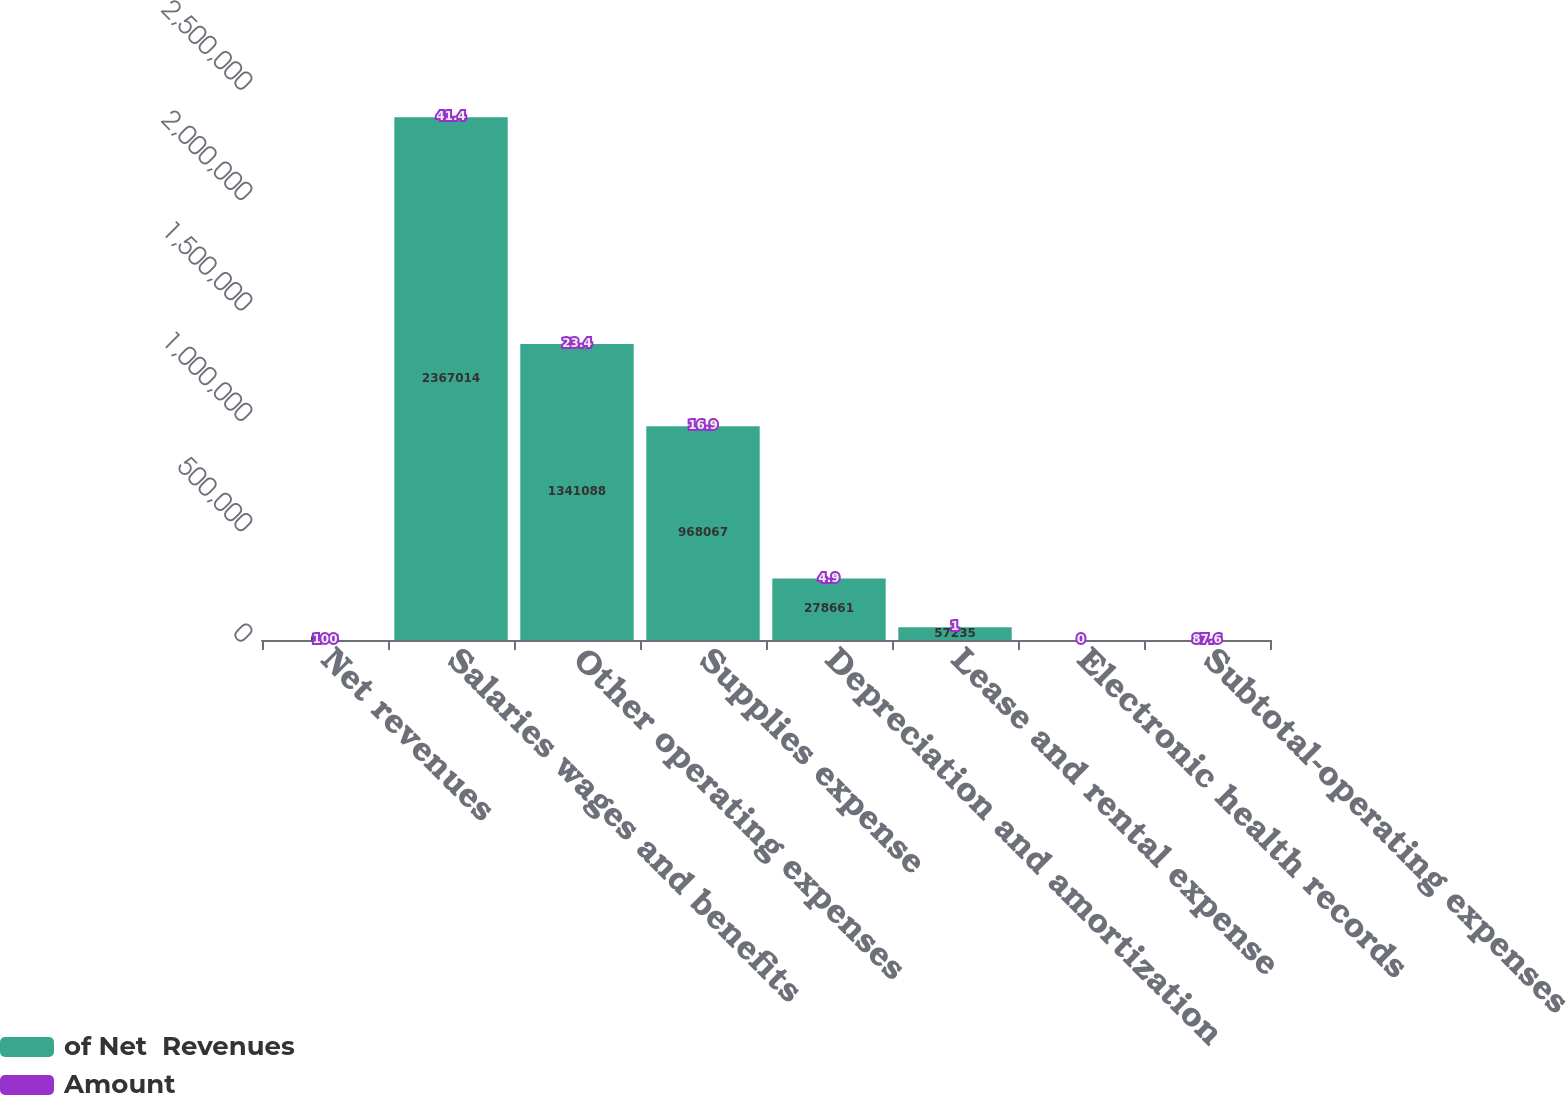<chart> <loc_0><loc_0><loc_500><loc_500><stacked_bar_chart><ecel><fcel>Net revenues<fcel>Salaries wages and benefits<fcel>Other operating expenses<fcel>Supplies expense<fcel>Depreciation and amortization<fcel>Lease and rental expense<fcel>Electronic health records<fcel>Subtotal-operating expenses<nl><fcel>of Net  Revenues<fcel>64.5<fcel>2.36701e+06<fcel>1.34109e+06<fcel>968067<fcel>278661<fcel>57235<fcel>0<fcel>64.5<nl><fcel>Amount<fcel>100<fcel>41.4<fcel>23.4<fcel>16.9<fcel>4.9<fcel>1<fcel>0<fcel>87.6<nl></chart> 